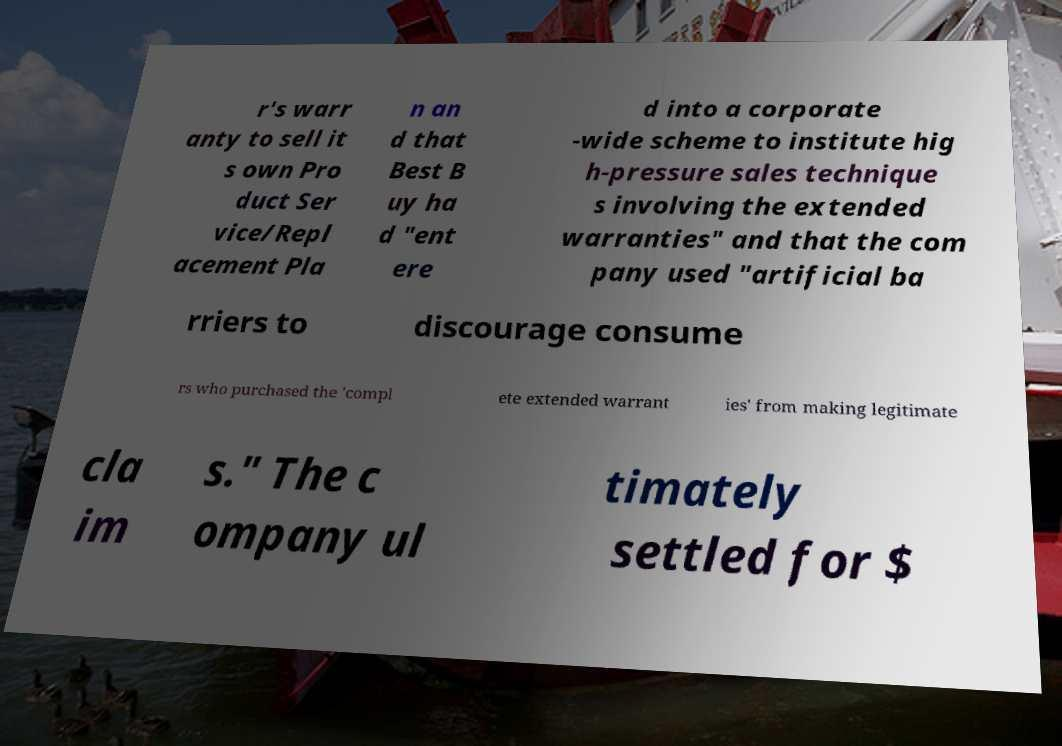Can you read and provide the text displayed in the image?This photo seems to have some interesting text. Can you extract and type it out for me? r's warr anty to sell it s own Pro duct Ser vice/Repl acement Pla n an d that Best B uy ha d "ent ere d into a corporate -wide scheme to institute hig h-pressure sales technique s involving the extended warranties" and that the com pany used "artificial ba rriers to discourage consume rs who purchased the 'compl ete extended warrant ies' from making legitimate cla im s." The c ompany ul timately settled for $ 